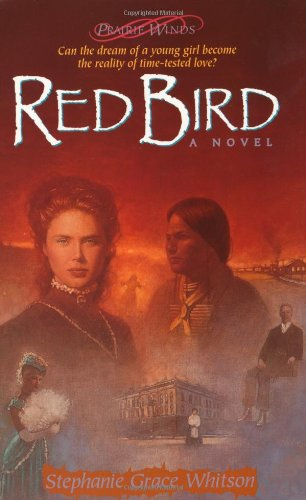Is this a religious book? Yes, 'Red Bird' incorporates religious elements and themes, typical of Stephanie Grace Whitson’s works in the Prairie Winds Series. 